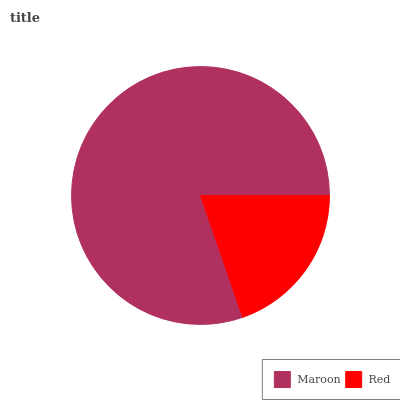Is Red the minimum?
Answer yes or no. Yes. Is Maroon the maximum?
Answer yes or no. Yes. Is Red the maximum?
Answer yes or no. No. Is Maroon greater than Red?
Answer yes or no. Yes. Is Red less than Maroon?
Answer yes or no. Yes. Is Red greater than Maroon?
Answer yes or no. No. Is Maroon less than Red?
Answer yes or no. No. Is Maroon the high median?
Answer yes or no. Yes. Is Red the low median?
Answer yes or no. Yes. Is Red the high median?
Answer yes or no. No. Is Maroon the low median?
Answer yes or no. No. 